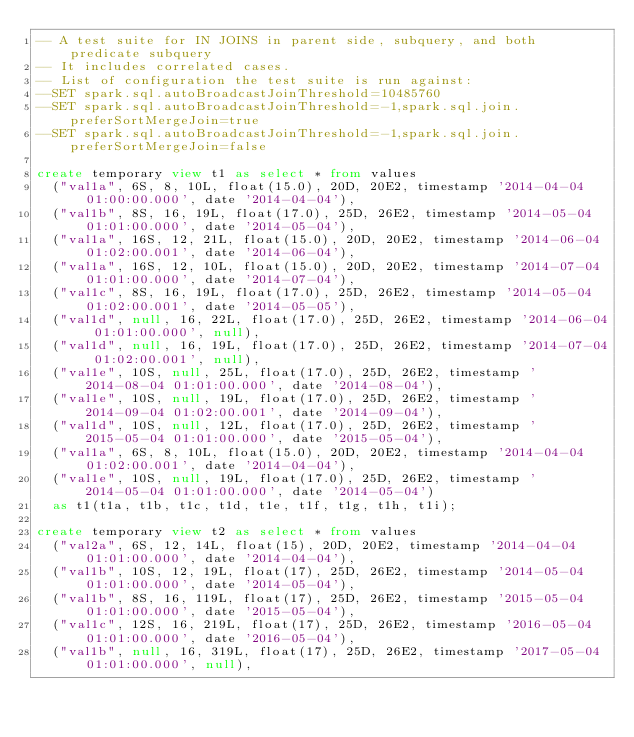<code> <loc_0><loc_0><loc_500><loc_500><_SQL_>-- A test suite for IN JOINS in parent side, subquery, and both predicate subquery
-- It includes correlated cases.
-- List of configuration the test suite is run against:
--SET spark.sql.autoBroadcastJoinThreshold=10485760
--SET spark.sql.autoBroadcastJoinThreshold=-1,spark.sql.join.preferSortMergeJoin=true
--SET spark.sql.autoBroadcastJoinThreshold=-1,spark.sql.join.preferSortMergeJoin=false

create temporary view t1 as select * from values
  ("val1a", 6S, 8, 10L, float(15.0), 20D, 20E2, timestamp '2014-04-04 01:00:00.000', date '2014-04-04'),
  ("val1b", 8S, 16, 19L, float(17.0), 25D, 26E2, timestamp '2014-05-04 01:01:00.000', date '2014-05-04'),
  ("val1a", 16S, 12, 21L, float(15.0), 20D, 20E2, timestamp '2014-06-04 01:02:00.001', date '2014-06-04'),
  ("val1a", 16S, 12, 10L, float(15.0), 20D, 20E2, timestamp '2014-07-04 01:01:00.000', date '2014-07-04'),
  ("val1c", 8S, 16, 19L, float(17.0), 25D, 26E2, timestamp '2014-05-04 01:02:00.001', date '2014-05-05'),
  ("val1d", null, 16, 22L, float(17.0), 25D, 26E2, timestamp '2014-06-04 01:01:00.000', null),
  ("val1d", null, 16, 19L, float(17.0), 25D, 26E2, timestamp '2014-07-04 01:02:00.001', null),
  ("val1e", 10S, null, 25L, float(17.0), 25D, 26E2, timestamp '2014-08-04 01:01:00.000', date '2014-08-04'),
  ("val1e", 10S, null, 19L, float(17.0), 25D, 26E2, timestamp '2014-09-04 01:02:00.001', date '2014-09-04'),
  ("val1d", 10S, null, 12L, float(17.0), 25D, 26E2, timestamp '2015-05-04 01:01:00.000', date '2015-05-04'),
  ("val1a", 6S, 8, 10L, float(15.0), 20D, 20E2, timestamp '2014-04-04 01:02:00.001', date '2014-04-04'),
  ("val1e", 10S, null, 19L, float(17.0), 25D, 26E2, timestamp '2014-05-04 01:01:00.000', date '2014-05-04')
  as t1(t1a, t1b, t1c, t1d, t1e, t1f, t1g, t1h, t1i);

create temporary view t2 as select * from values
  ("val2a", 6S, 12, 14L, float(15), 20D, 20E2, timestamp '2014-04-04 01:01:00.000', date '2014-04-04'),
  ("val1b", 10S, 12, 19L, float(17), 25D, 26E2, timestamp '2014-05-04 01:01:00.000', date '2014-05-04'),
  ("val1b", 8S, 16, 119L, float(17), 25D, 26E2, timestamp '2015-05-04 01:01:00.000', date '2015-05-04'),
  ("val1c", 12S, 16, 219L, float(17), 25D, 26E2, timestamp '2016-05-04 01:01:00.000', date '2016-05-04'),
  ("val1b", null, 16, 319L, float(17), 25D, 26E2, timestamp '2017-05-04 01:01:00.000', null),</code> 